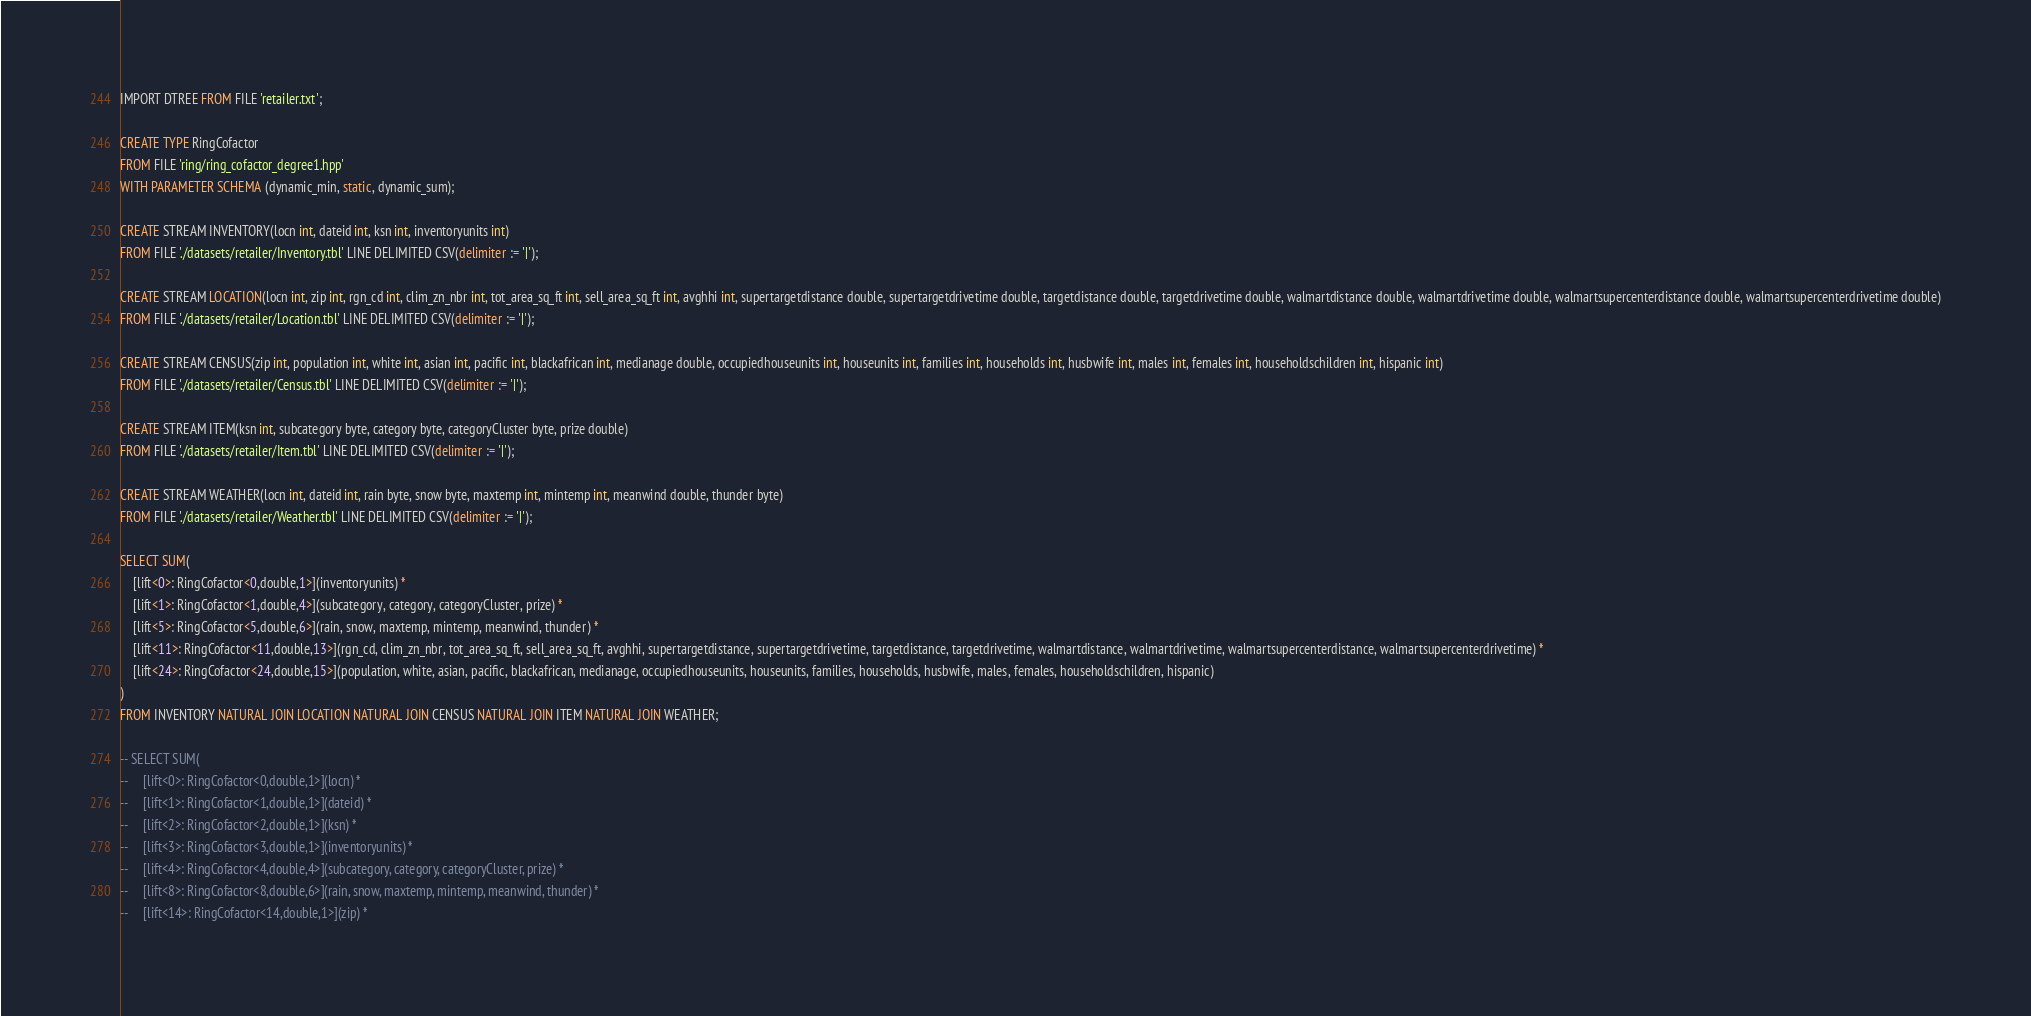Convert code to text. <code><loc_0><loc_0><loc_500><loc_500><_SQL_>IMPORT DTREE FROM FILE 'retailer.txt';

CREATE TYPE RingCofactor
FROM FILE 'ring/ring_cofactor_degree1.hpp'
WITH PARAMETER SCHEMA (dynamic_min, static, dynamic_sum);

CREATE STREAM INVENTORY(locn int, dateid int, ksn int, inventoryunits int)
FROM FILE './datasets/retailer/Inventory.tbl' LINE DELIMITED CSV(delimiter := '|');

CREATE STREAM LOCATION(locn int, zip int, rgn_cd int, clim_zn_nbr int, tot_area_sq_ft int, sell_area_sq_ft int, avghhi int, supertargetdistance double, supertargetdrivetime double, targetdistance double, targetdrivetime double, walmartdistance double, walmartdrivetime double, walmartsupercenterdistance double, walmartsupercenterdrivetime double)
FROM FILE './datasets/retailer/Location.tbl' LINE DELIMITED CSV(delimiter := '|');

CREATE STREAM CENSUS(zip int, population int, white int, asian int, pacific int, blackafrican int, medianage double, occupiedhouseunits int, houseunits int, families int, households int, husbwife int, males int, females int, householdschildren int, hispanic int)
FROM FILE './datasets/retailer/Census.tbl' LINE DELIMITED CSV(delimiter := '|');

CREATE STREAM ITEM(ksn int, subcategory byte, category byte, categoryCluster byte, prize double) 
FROM FILE './datasets/retailer/Item.tbl' LINE DELIMITED CSV(delimiter := '|');

CREATE STREAM WEATHER(locn int, dateid int, rain byte, snow byte, maxtemp int, mintemp int, meanwind double, thunder byte) 
FROM FILE './datasets/retailer/Weather.tbl' LINE DELIMITED CSV(delimiter := '|');

SELECT SUM(
    [lift<0>: RingCofactor<0,double,1>](inventoryunits) *
    [lift<1>: RingCofactor<1,double,4>](subcategory, category, categoryCluster, prize) *
    [lift<5>: RingCofactor<5,double,6>](rain, snow, maxtemp, mintemp, meanwind, thunder) *
    [lift<11>: RingCofactor<11,double,13>](rgn_cd, clim_zn_nbr, tot_area_sq_ft, sell_area_sq_ft, avghhi, supertargetdistance, supertargetdrivetime, targetdistance, targetdrivetime, walmartdistance, walmartdrivetime, walmartsupercenterdistance, walmartsupercenterdrivetime) *
    [lift<24>: RingCofactor<24,double,15>](population, white, asian, pacific, blackafrican, medianage, occupiedhouseunits, houseunits, families, households, husbwife, males, females, householdschildren, hispanic)
)
FROM INVENTORY NATURAL JOIN LOCATION NATURAL JOIN CENSUS NATURAL JOIN ITEM NATURAL JOIN WEATHER;

-- SELECT SUM(
--     [lift<0>: RingCofactor<0,double,1>](locn) *
--     [lift<1>: RingCofactor<1,double,1>](dateid) *
--     [lift<2>: RingCofactor<2,double,1>](ksn) *
--     [lift<3>: RingCofactor<3,double,1>](inventoryunits) *
--     [lift<4>: RingCofactor<4,double,4>](subcategory, category, categoryCluster, prize) *
--     [lift<8>: RingCofactor<8,double,6>](rain, snow, maxtemp, mintemp, meanwind, thunder) *
--     [lift<14>: RingCofactor<14,double,1>](zip) *</code> 